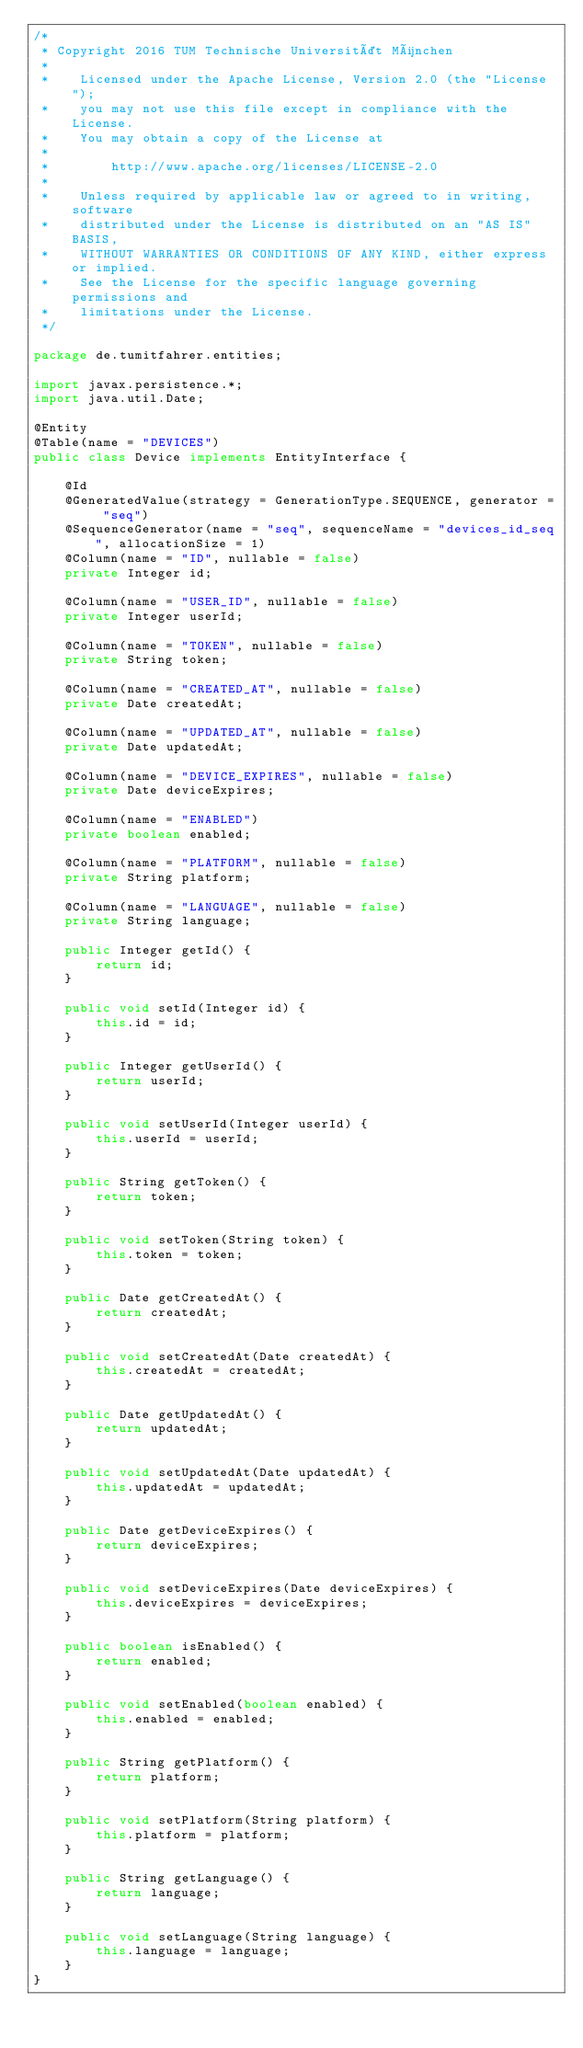Convert code to text. <code><loc_0><loc_0><loc_500><loc_500><_Java_>/*
 * Copyright 2016 TUM Technische Universität München
 *
 *    Licensed under the Apache License, Version 2.0 (the "License");
 *    you may not use this file except in compliance with the License.
 *    You may obtain a copy of the License at
 *
 *        http://www.apache.org/licenses/LICENSE-2.0
 *
 *    Unless required by applicable law or agreed to in writing, software
 *    distributed under the License is distributed on an "AS IS" BASIS,
 *    WITHOUT WARRANTIES OR CONDITIONS OF ANY KIND, either express or implied.
 *    See the License for the specific language governing permissions and
 *    limitations under the License.
 */

package de.tumitfahrer.entities;

import javax.persistence.*;
import java.util.Date;

@Entity
@Table(name = "DEVICES")
public class Device implements EntityInterface {

    @Id
    @GeneratedValue(strategy = GenerationType.SEQUENCE, generator = "seq")
    @SequenceGenerator(name = "seq", sequenceName = "devices_id_seq", allocationSize = 1)
    @Column(name = "ID", nullable = false)
    private Integer id;

    @Column(name = "USER_ID", nullable = false)
    private Integer userId;

    @Column(name = "TOKEN", nullable = false)
    private String token;

    @Column(name = "CREATED_AT", nullable = false)
    private Date createdAt;

    @Column(name = "UPDATED_AT", nullable = false)
    private Date updatedAt;

    @Column(name = "DEVICE_EXPIRES", nullable = false)
    private Date deviceExpires;

    @Column(name = "ENABLED")
    private boolean enabled;

    @Column(name = "PLATFORM", nullable = false)
    private String platform;

    @Column(name = "LANGUAGE", nullable = false)
    private String language;

    public Integer getId() {
        return id;
    }

    public void setId(Integer id) {
        this.id = id;
    }

    public Integer getUserId() {
        return userId;
    }

    public void setUserId(Integer userId) {
        this.userId = userId;
    }

    public String getToken() {
        return token;
    }

    public void setToken(String token) {
        this.token = token;
    }

    public Date getCreatedAt() {
        return createdAt;
    }

    public void setCreatedAt(Date createdAt) {
        this.createdAt = createdAt;
    }

    public Date getUpdatedAt() {
        return updatedAt;
    }

    public void setUpdatedAt(Date updatedAt) {
        this.updatedAt = updatedAt;
    }

    public Date getDeviceExpires() {
        return deviceExpires;
    }

    public void setDeviceExpires(Date deviceExpires) {
        this.deviceExpires = deviceExpires;
    }

    public boolean isEnabled() {
        return enabled;
    }

    public void setEnabled(boolean enabled) {
        this.enabled = enabled;
    }

    public String getPlatform() {
        return platform;
    }

    public void setPlatform(String platform) {
        this.platform = platform;
    }

    public String getLanguage() {
        return language;
    }

    public void setLanguage(String language) {
        this.language = language;
    }
}</code> 